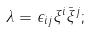Convert formula to latex. <formula><loc_0><loc_0><loc_500><loc_500>\lambda = \epsilon _ { i j } \xi ^ { i } \bar { \xi } ^ { j } ;</formula> 